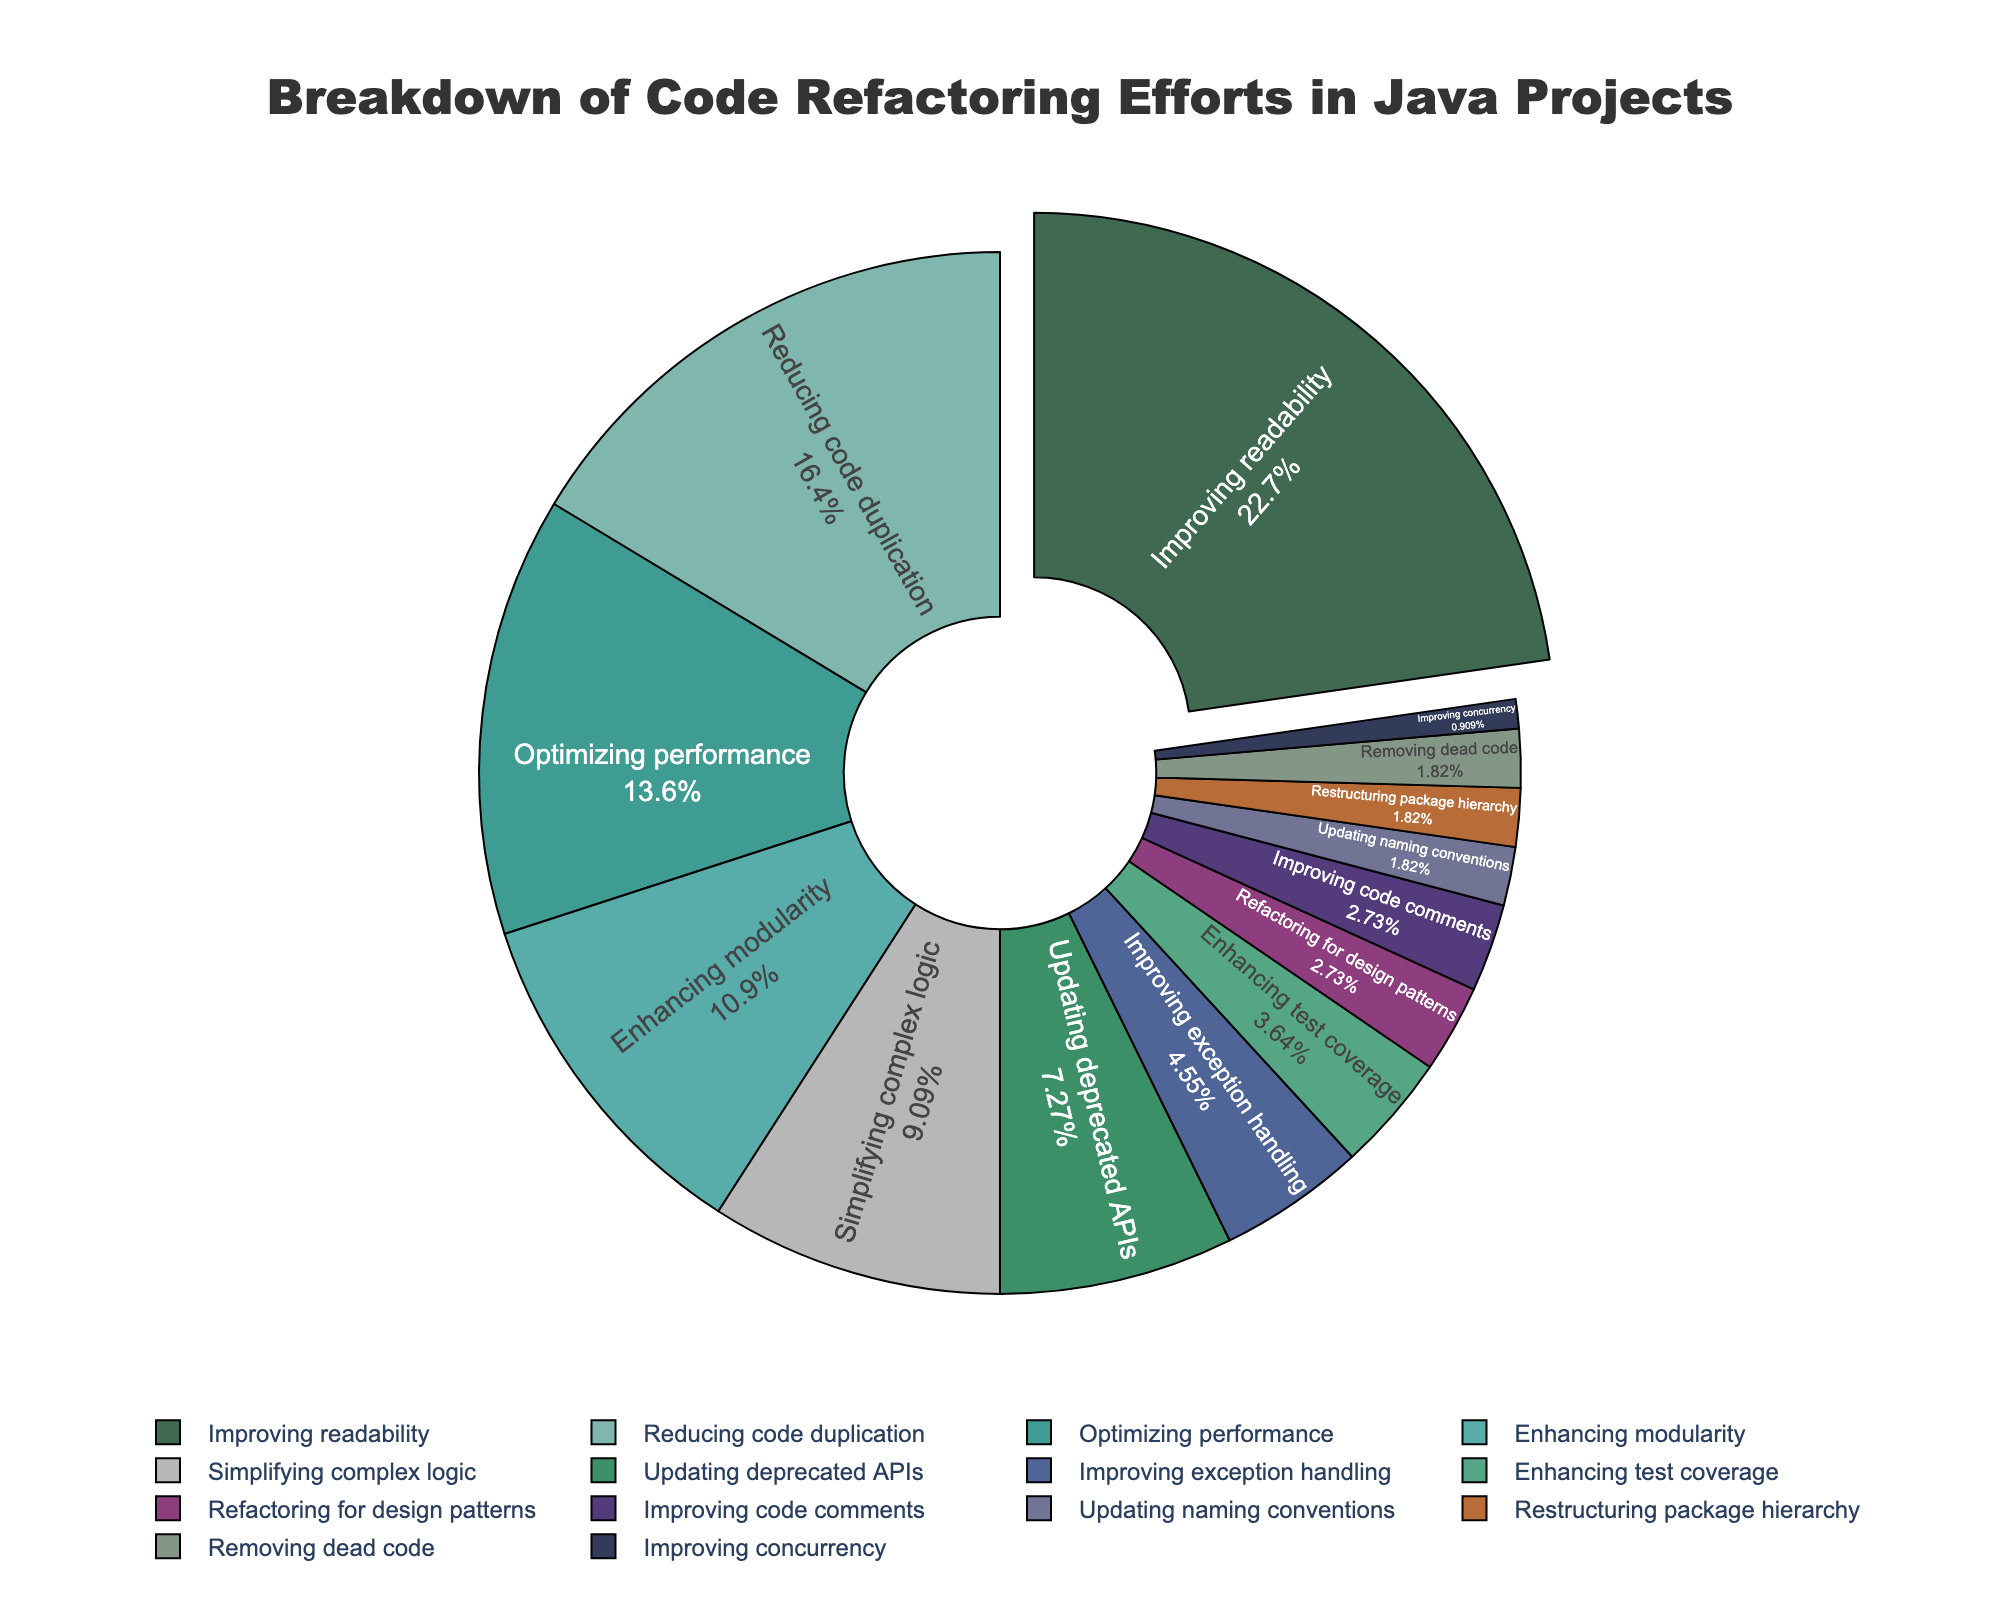What's the largest category in terms of code refactoring efforts? The largest category can be identified by looking at the segment with the highest percentage in the pie chart. By examining the figure, it is clear that "Improving readability" has the largest segment at 25%.
Answer: Improving readability Which category has the lowest percentage of code refactoring efforts? The smallest category corresponds to the segment with the smallest percentage in the pie chart. Observing the figure, "Improving concurrency" has the smallest segment, with a 1% share.
Answer: Improving concurrency How much more effort is put into improving readability compared to improving exception handling? First, identify the percentages for both "Improving readability" (25%) and "Improving exception handling" (5%). The difference can be calculated as 25% - 5% = 20%. Therefore, 20% more effort is put into improving readability.
Answer: 20% What's the combined percentage for "Improving readability" and "Reducing code duplication"? From the pie chart, "Improving readability" accounts for 25% and "Reducing code duplication" makes up 18%. Adding these together, 25% + 18% = 43%.
Answer: 43% Are there more efforts in "Optimizing performance" or "Enhancing modularity"? Look at the segments for both categories. "Optimizing performance" has a segment of 15%, while "Enhancing modularity" has 12%. Therefore, more efforts are put into "Optimizing performance".
Answer: Optimizing performance Compared to "Updating deprecated APIs," how much more focus is there on "Simplifying complex logic"? Identify the percentages for "Updating deprecated APIs" (8%) and "Simplifying complex logic" (10%). Subtract the former from the latter: 10% - 8% = 2%. Therefore, 2% more focus is on simplifying complex logic.
Answer: 2% What is the total percentage attributed to categories that individually have 5% or less? Categories with 5% or less are "Improving exception handling" (5%), "Enhancing test coverage" (4%), "Refactoring for design patterns" (3%), "Improving code comments" (3%), "Updating naming conventions" (2%), "Restructuring package hierarchy" (2%), "Removing dead code" (2%), and "Improving concurrency" (1%). Summing these values: 5% + 4% + 3% + 3% + 2% + 2% + 2% + 1% = 22%.
Answer: 22% Which category is visually emphasized in the pie chart, and why? The visually emphasized category can be identified by a segment that is pulled out from the rest of the chart. Observing the pie chart, "Improving readability" is the one pulled out, which makes it visually emphasized.
Answer: Improving readability What proportion of efforts is dedicated to updating or improving existing code (readability, performance, exception handling, deprecated APIs)? First, identify the percentages for the relevant categories: "Improving readability" (25%), "Optimizing performance" (15%), "Improving exception handling" (5%), and "Updating deprecated APIs" (8%). Summing these values: 25% + 15% + 5% + 8% = 53% of efforts are dedicated to updating or improving existing code.
Answer: 53% 